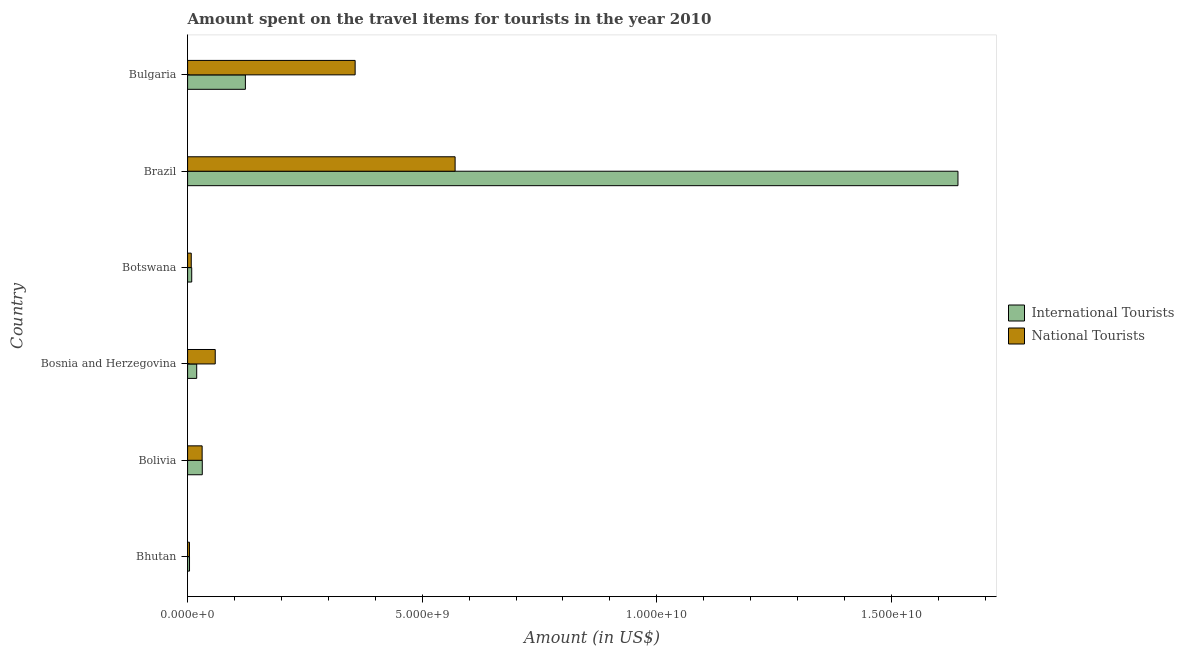How many groups of bars are there?
Give a very brief answer. 6. Are the number of bars on each tick of the Y-axis equal?
Your response must be concise. Yes. How many bars are there on the 2nd tick from the top?
Provide a short and direct response. 2. What is the label of the 3rd group of bars from the top?
Offer a very short reply. Botswana. What is the amount spent on travel items of international tourists in Botswana?
Give a very brief answer. 8.80e+07. Across all countries, what is the maximum amount spent on travel items of national tourists?
Provide a short and direct response. 5.70e+09. Across all countries, what is the minimum amount spent on travel items of national tourists?
Keep it short and to the point. 4.00e+07. In which country was the amount spent on travel items of international tourists maximum?
Provide a succinct answer. Brazil. In which country was the amount spent on travel items of national tourists minimum?
Offer a very short reply. Bhutan. What is the total amount spent on travel items of national tourists in the graph?
Your response must be concise. 1.03e+1. What is the difference between the amount spent on travel items of international tourists in Bhutan and that in Brazil?
Your answer should be very brief. -1.64e+1. What is the difference between the amount spent on travel items of national tourists in Botswana and the amount spent on travel items of international tourists in Bosnia and Herzegovina?
Offer a very short reply. -1.16e+08. What is the average amount spent on travel items of national tourists per country?
Ensure brevity in your answer.  1.72e+09. What is the difference between the amount spent on travel items of national tourists and amount spent on travel items of international tourists in Bosnia and Herzegovina?
Offer a terse response. 3.95e+08. In how many countries, is the amount spent on travel items of international tourists greater than 13000000000 US$?
Provide a succinct answer. 1. What is the ratio of the amount spent on travel items of national tourists in Bolivia to that in Botswana?
Ensure brevity in your answer.  3.97. Is the difference between the amount spent on travel items of international tourists in Botswana and Brazil greater than the difference between the amount spent on travel items of national tourists in Botswana and Brazil?
Your answer should be very brief. No. What is the difference between the highest and the second highest amount spent on travel items of international tourists?
Provide a short and direct response. 1.52e+1. What is the difference between the highest and the lowest amount spent on travel items of international tourists?
Offer a terse response. 1.64e+1. In how many countries, is the amount spent on travel items of international tourists greater than the average amount spent on travel items of international tourists taken over all countries?
Your answer should be very brief. 1. What does the 1st bar from the top in Bhutan represents?
Provide a short and direct response. National Tourists. What does the 2nd bar from the bottom in Bosnia and Herzegovina represents?
Provide a short and direct response. National Tourists. What is the difference between two consecutive major ticks on the X-axis?
Offer a very short reply. 5.00e+09. Does the graph contain any zero values?
Ensure brevity in your answer.  No. Does the graph contain grids?
Offer a terse response. No. What is the title of the graph?
Offer a very short reply. Amount spent on the travel items for tourists in the year 2010. What is the Amount (in US$) in International Tourists in Bhutan?
Offer a terse response. 4.10e+07. What is the Amount (in US$) of National Tourists in Bhutan?
Offer a very short reply. 4.00e+07. What is the Amount (in US$) of International Tourists in Bolivia?
Give a very brief answer. 3.13e+08. What is the Amount (in US$) in National Tourists in Bolivia?
Offer a terse response. 3.10e+08. What is the Amount (in US$) of International Tourists in Bosnia and Herzegovina?
Ensure brevity in your answer.  1.94e+08. What is the Amount (in US$) in National Tourists in Bosnia and Herzegovina?
Your answer should be compact. 5.89e+08. What is the Amount (in US$) in International Tourists in Botswana?
Make the answer very short. 8.80e+07. What is the Amount (in US$) of National Tourists in Botswana?
Give a very brief answer. 7.80e+07. What is the Amount (in US$) of International Tourists in Brazil?
Your response must be concise. 1.64e+1. What is the Amount (in US$) of National Tourists in Brazil?
Make the answer very short. 5.70e+09. What is the Amount (in US$) of International Tourists in Bulgaria?
Your answer should be very brief. 1.23e+09. What is the Amount (in US$) of National Tourists in Bulgaria?
Keep it short and to the point. 3.57e+09. Across all countries, what is the maximum Amount (in US$) of International Tourists?
Your answer should be very brief. 1.64e+1. Across all countries, what is the maximum Amount (in US$) of National Tourists?
Provide a succinct answer. 5.70e+09. Across all countries, what is the minimum Amount (in US$) of International Tourists?
Offer a very short reply. 4.10e+07. Across all countries, what is the minimum Amount (in US$) of National Tourists?
Your answer should be compact. 4.00e+07. What is the total Amount (in US$) in International Tourists in the graph?
Give a very brief answer. 1.83e+1. What is the total Amount (in US$) of National Tourists in the graph?
Give a very brief answer. 1.03e+1. What is the difference between the Amount (in US$) in International Tourists in Bhutan and that in Bolivia?
Provide a short and direct response. -2.72e+08. What is the difference between the Amount (in US$) of National Tourists in Bhutan and that in Bolivia?
Make the answer very short. -2.70e+08. What is the difference between the Amount (in US$) of International Tourists in Bhutan and that in Bosnia and Herzegovina?
Ensure brevity in your answer.  -1.53e+08. What is the difference between the Amount (in US$) of National Tourists in Bhutan and that in Bosnia and Herzegovina?
Give a very brief answer. -5.49e+08. What is the difference between the Amount (in US$) of International Tourists in Bhutan and that in Botswana?
Provide a succinct answer. -4.70e+07. What is the difference between the Amount (in US$) in National Tourists in Bhutan and that in Botswana?
Provide a short and direct response. -3.80e+07. What is the difference between the Amount (in US$) in International Tourists in Bhutan and that in Brazil?
Ensure brevity in your answer.  -1.64e+1. What is the difference between the Amount (in US$) of National Tourists in Bhutan and that in Brazil?
Your response must be concise. -5.66e+09. What is the difference between the Amount (in US$) in International Tourists in Bhutan and that in Bulgaria?
Offer a very short reply. -1.19e+09. What is the difference between the Amount (in US$) of National Tourists in Bhutan and that in Bulgaria?
Provide a short and direct response. -3.53e+09. What is the difference between the Amount (in US$) in International Tourists in Bolivia and that in Bosnia and Herzegovina?
Offer a terse response. 1.19e+08. What is the difference between the Amount (in US$) in National Tourists in Bolivia and that in Bosnia and Herzegovina?
Your answer should be very brief. -2.79e+08. What is the difference between the Amount (in US$) in International Tourists in Bolivia and that in Botswana?
Offer a very short reply. 2.25e+08. What is the difference between the Amount (in US$) of National Tourists in Bolivia and that in Botswana?
Offer a very short reply. 2.32e+08. What is the difference between the Amount (in US$) in International Tourists in Bolivia and that in Brazil?
Keep it short and to the point. -1.61e+1. What is the difference between the Amount (in US$) in National Tourists in Bolivia and that in Brazil?
Give a very brief answer. -5.39e+09. What is the difference between the Amount (in US$) of International Tourists in Bolivia and that in Bulgaria?
Offer a terse response. -9.19e+08. What is the difference between the Amount (in US$) of National Tourists in Bolivia and that in Bulgaria?
Your answer should be compact. -3.26e+09. What is the difference between the Amount (in US$) of International Tourists in Bosnia and Herzegovina and that in Botswana?
Keep it short and to the point. 1.06e+08. What is the difference between the Amount (in US$) of National Tourists in Bosnia and Herzegovina and that in Botswana?
Ensure brevity in your answer.  5.11e+08. What is the difference between the Amount (in US$) of International Tourists in Bosnia and Herzegovina and that in Brazil?
Provide a succinct answer. -1.62e+1. What is the difference between the Amount (in US$) of National Tourists in Bosnia and Herzegovina and that in Brazil?
Offer a very short reply. -5.11e+09. What is the difference between the Amount (in US$) in International Tourists in Bosnia and Herzegovina and that in Bulgaria?
Make the answer very short. -1.04e+09. What is the difference between the Amount (in US$) of National Tourists in Bosnia and Herzegovina and that in Bulgaria?
Give a very brief answer. -2.98e+09. What is the difference between the Amount (in US$) of International Tourists in Botswana and that in Brazil?
Provide a succinct answer. -1.63e+1. What is the difference between the Amount (in US$) in National Tourists in Botswana and that in Brazil?
Give a very brief answer. -5.62e+09. What is the difference between the Amount (in US$) in International Tourists in Botswana and that in Bulgaria?
Your response must be concise. -1.14e+09. What is the difference between the Amount (in US$) in National Tourists in Botswana and that in Bulgaria?
Offer a terse response. -3.49e+09. What is the difference between the Amount (in US$) of International Tourists in Brazil and that in Bulgaria?
Provide a short and direct response. 1.52e+1. What is the difference between the Amount (in US$) of National Tourists in Brazil and that in Bulgaria?
Give a very brief answer. 2.13e+09. What is the difference between the Amount (in US$) in International Tourists in Bhutan and the Amount (in US$) in National Tourists in Bolivia?
Your answer should be very brief. -2.69e+08. What is the difference between the Amount (in US$) of International Tourists in Bhutan and the Amount (in US$) of National Tourists in Bosnia and Herzegovina?
Ensure brevity in your answer.  -5.48e+08. What is the difference between the Amount (in US$) of International Tourists in Bhutan and the Amount (in US$) of National Tourists in Botswana?
Ensure brevity in your answer.  -3.70e+07. What is the difference between the Amount (in US$) of International Tourists in Bhutan and the Amount (in US$) of National Tourists in Brazil?
Your answer should be compact. -5.66e+09. What is the difference between the Amount (in US$) in International Tourists in Bhutan and the Amount (in US$) in National Tourists in Bulgaria?
Make the answer very short. -3.53e+09. What is the difference between the Amount (in US$) of International Tourists in Bolivia and the Amount (in US$) of National Tourists in Bosnia and Herzegovina?
Give a very brief answer. -2.76e+08. What is the difference between the Amount (in US$) in International Tourists in Bolivia and the Amount (in US$) in National Tourists in Botswana?
Make the answer very short. 2.35e+08. What is the difference between the Amount (in US$) in International Tourists in Bolivia and the Amount (in US$) in National Tourists in Brazil?
Keep it short and to the point. -5.39e+09. What is the difference between the Amount (in US$) of International Tourists in Bolivia and the Amount (in US$) of National Tourists in Bulgaria?
Provide a short and direct response. -3.26e+09. What is the difference between the Amount (in US$) in International Tourists in Bosnia and Herzegovina and the Amount (in US$) in National Tourists in Botswana?
Make the answer very short. 1.16e+08. What is the difference between the Amount (in US$) in International Tourists in Bosnia and Herzegovina and the Amount (in US$) in National Tourists in Brazil?
Your answer should be very brief. -5.51e+09. What is the difference between the Amount (in US$) in International Tourists in Bosnia and Herzegovina and the Amount (in US$) in National Tourists in Bulgaria?
Give a very brief answer. -3.38e+09. What is the difference between the Amount (in US$) of International Tourists in Botswana and the Amount (in US$) of National Tourists in Brazil?
Offer a terse response. -5.61e+09. What is the difference between the Amount (in US$) of International Tourists in Botswana and the Amount (in US$) of National Tourists in Bulgaria?
Provide a succinct answer. -3.48e+09. What is the difference between the Amount (in US$) in International Tourists in Brazil and the Amount (in US$) in National Tourists in Bulgaria?
Provide a succinct answer. 1.28e+1. What is the average Amount (in US$) of International Tourists per country?
Your answer should be very brief. 3.05e+09. What is the average Amount (in US$) in National Tourists per country?
Your answer should be compact. 1.72e+09. What is the difference between the Amount (in US$) of International Tourists and Amount (in US$) of National Tourists in Bosnia and Herzegovina?
Your answer should be compact. -3.95e+08. What is the difference between the Amount (in US$) of International Tourists and Amount (in US$) of National Tourists in Brazil?
Make the answer very short. 1.07e+1. What is the difference between the Amount (in US$) in International Tourists and Amount (in US$) in National Tourists in Bulgaria?
Offer a terse response. -2.34e+09. What is the ratio of the Amount (in US$) in International Tourists in Bhutan to that in Bolivia?
Ensure brevity in your answer.  0.13. What is the ratio of the Amount (in US$) in National Tourists in Bhutan to that in Bolivia?
Provide a succinct answer. 0.13. What is the ratio of the Amount (in US$) of International Tourists in Bhutan to that in Bosnia and Herzegovina?
Your response must be concise. 0.21. What is the ratio of the Amount (in US$) in National Tourists in Bhutan to that in Bosnia and Herzegovina?
Make the answer very short. 0.07. What is the ratio of the Amount (in US$) in International Tourists in Bhutan to that in Botswana?
Your answer should be compact. 0.47. What is the ratio of the Amount (in US$) of National Tourists in Bhutan to that in Botswana?
Your response must be concise. 0.51. What is the ratio of the Amount (in US$) in International Tourists in Bhutan to that in Brazil?
Ensure brevity in your answer.  0. What is the ratio of the Amount (in US$) of National Tourists in Bhutan to that in Brazil?
Offer a terse response. 0.01. What is the ratio of the Amount (in US$) of International Tourists in Bhutan to that in Bulgaria?
Keep it short and to the point. 0.03. What is the ratio of the Amount (in US$) of National Tourists in Bhutan to that in Bulgaria?
Your response must be concise. 0.01. What is the ratio of the Amount (in US$) of International Tourists in Bolivia to that in Bosnia and Herzegovina?
Offer a very short reply. 1.61. What is the ratio of the Amount (in US$) in National Tourists in Bolivia to that in Bosnia and Herzegovina?
Your answer should be very brief. 0.53. What is the ratio of the Amount (in US$) in International Tourists in Bolivia to that in Botswana?
Make the answer very short. 3.56. What is the ratio of the Amount (in US$) in National Tourists in Bolivia to that in Botswana?
Provide a succinct answer. 3.97. What is the ratio of the Amount (in US$) in International Tourists in Bolivia to that in Brazil?
Provide a short and direct response. 0.02. What is the ratio of the Amount (in US$) of National Tourists in Bolivia to that in Brazil?
Provide a succinct answer. 0.05. What is the ratio of the Amount (in US$) in International Tourists in Bolivia to that in Bulgaria?
Offer a very short reply. 0.25. What is the ratio of the Amount (in US$) in National Tourists in Bolivia to that in Bulgaria?
Make the answer very short. 0.09. What is the ratio of the Amount (in US$) in International Tourists in Bosnia and Herzegovina to that in Botswana?
Give a very brief answer. 2.2. What is the ratio of the Amount (in US$) of National Tourists in Bosnia and Herzegovina to that in Botswana?
Provide a short and direct response. 7.55. What is the ratio of the Amount (in US$) of International Tourists in Bosnia and Herzegovina to that in Brazil?
Give a very brief answer. 0.01. What is the ratio of the Amount (in US$) of National Tourists in Bosnia and Herzegovina to that in Brazil?
Keep it short and to the point. 0.1. What is the ratio of the Amount (in US$) of International Tourists in Bosnia and Herzegovina to that in Bulgaria?
Keep it short and to the point. 0.16. What is the ratio of the Amount (in US$) in National Tourists in Bosnia and Herzegovina to that in Bulgaria?
Offer a very short reply. 0.16. What is the ratio of the Amount (in US$) of International Tourists in Botswana to that in Brazil?
Your response must be concise. 0.01. What is the ratio of the Amount (in US$) in National Tourists in Botswana to that in Brazil?
Offer a terse response. 0.01. What is the ratio of the Amount (in US$) in International Tourists in Botswana to that in Bulgaria?
Offer a very short reply. 0.07. What is the ratio of the Amount (in US$) of National Tourists in Botswana to that in Bulgaria?
Give a very brief answer. 0.02. What is the ratio of the Amount (in US$) in International Tourists in Brazil to that in Bulgaria?
Offer a terse response. 13.33. What is the ratio of the Amount (in US$) of National Tourists in Brazil to that in Bulgaria?
Offer a terse response. 1.6. What is the difference between the highest and the second highest Amount (in US$) in International Tourists?
Your response must be concise. 1.52e+1. What is the difference between the highest and the second highest Amount (in US$) in National Tourists?
Keep it short and to the point. 2.13e+09. What is the difference between the highest and the lowest Amount (in US$) of International Tourists?
Give a very brief answer. 1.64e+1. What is the difference between the highest and the lowest Amount (in US$) in National Tourists?
Keep it short and to the point. 5.66e+09. 